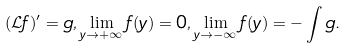Convert formula to latex. <formula><loc_0><loc_0><loc_500><loc_500>( \mathcal { L } f ) ^ { \prime } = g , \lim _ { y \rightarrow + \infty } f ( y ) = 0 , \lim _ { y \rightarrow - \infty } f ( y ) = - \int g .</formula> 